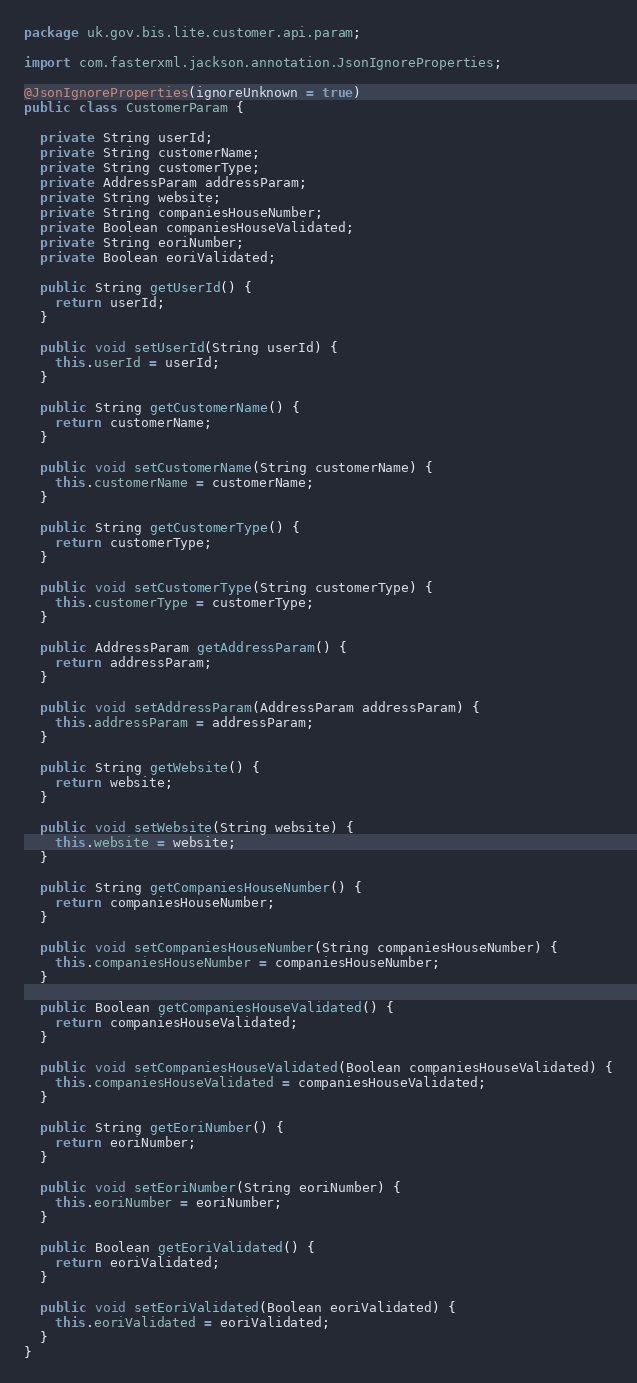<code> <loc_0><loc_0><loc_500><loc_500><_Java_>package uk.gov.bis.lite.customer.api.param;

import com.fasterxml.jackson.annotation.JsonIgnoreProperties;

@JsonIgnoreProperties(ignoreUnknown = true)
public class CustomerParam {

  private String userId;
  private String customerName;
  private String customerType;
  private AddressParam addressParam;
  private String website;
  private String companiesHouseNumber;
  private Boolean companiesHouseValidated;
  private String eoriNumber;
  private Boolean eoriValidated;

  public String getUserId() {
    return userId;
  }

  public void setUserId(String userId) {
    this.userId = userId;
  }

  public String getCustomerName() {
    return customerName;
  }

  public void setCustomerName(String customerName) {
    this.customerName = customerName;
  }

  public String getCustomerType() {
    return customerType;
  }

  public void setCustomerType(String customerType) {
    this.customerType = customerType;
  }

  public AddressParam getAddressParam() {
    return addressParam;
  }

  public void setAddressParam(AddressParam addressParam) {
    this.addressParam = addressParam;
  }

  public String getWebsite() {
    return website;
  }

  public void setWebsite(String website) {
    this.website = website;
  }

  public String getCompaniesHouseNumber() {
    return companiesHouseNumber;
  }

  public void setCompaniesHouseNumber(String companiesHouseNumber) {
    this.companiesHouseNumber = companiesHouseNumber;
  }

  public Boolean getCompaniesHouseValidated() {
    return companiesHouseValidated;
  }

  public void setCompaniesHouseValidated(Boolean companiesHouseValidated) {
    this.companiesHouseValidated = companiesHouseValidated;
  }

  public String getEoriNumber() {
    return eoriNumber;
  }

  public void setEoriNumber(String eoriNumber) {
    this.eoriNumber = eoriNumber;
  }

  public Boolean getEoriValidated() {
    return eoriValidated;
  }

  public void setEoriValidated(Boolean eoriValidated) {
    this.eoriValidated = eoriValidated;
  }
}
</code> 